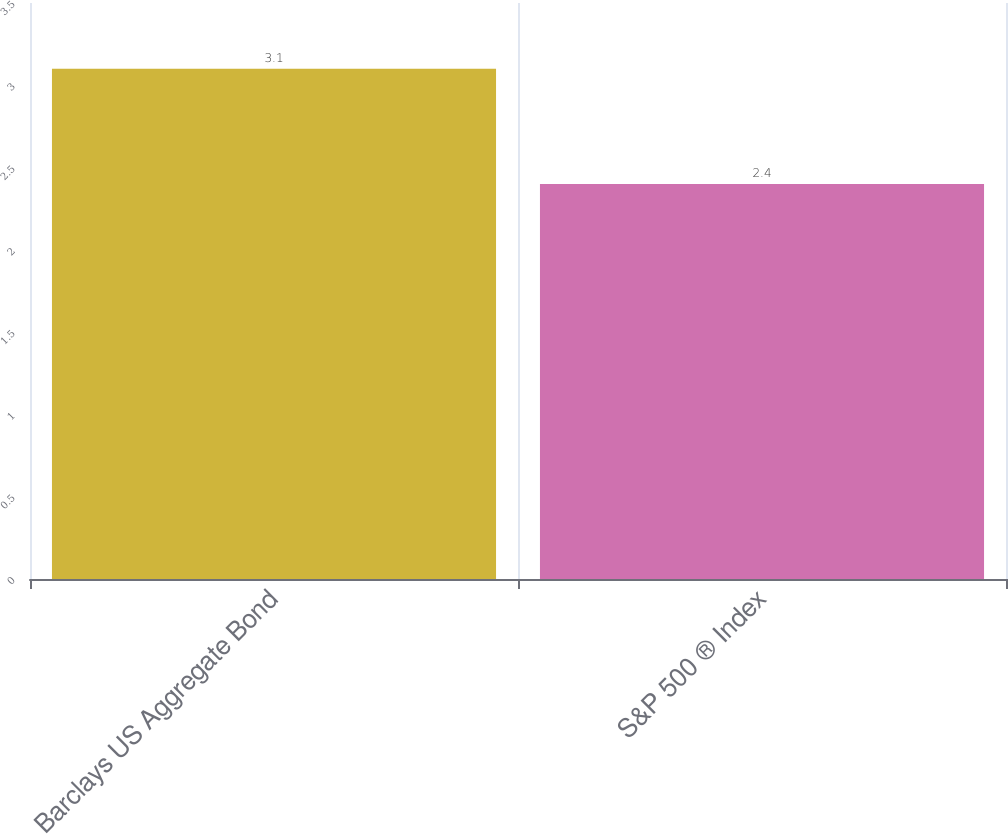Convert chart to OTSL. <chart><loc_0><loc_0><loc_500><loc_500><bar_chart><fcel>Barclays US Aggregate Bond<fcel>S&P 500 ® Index<nl><fcel>3.1<fcel>2.4<nl></chart> 